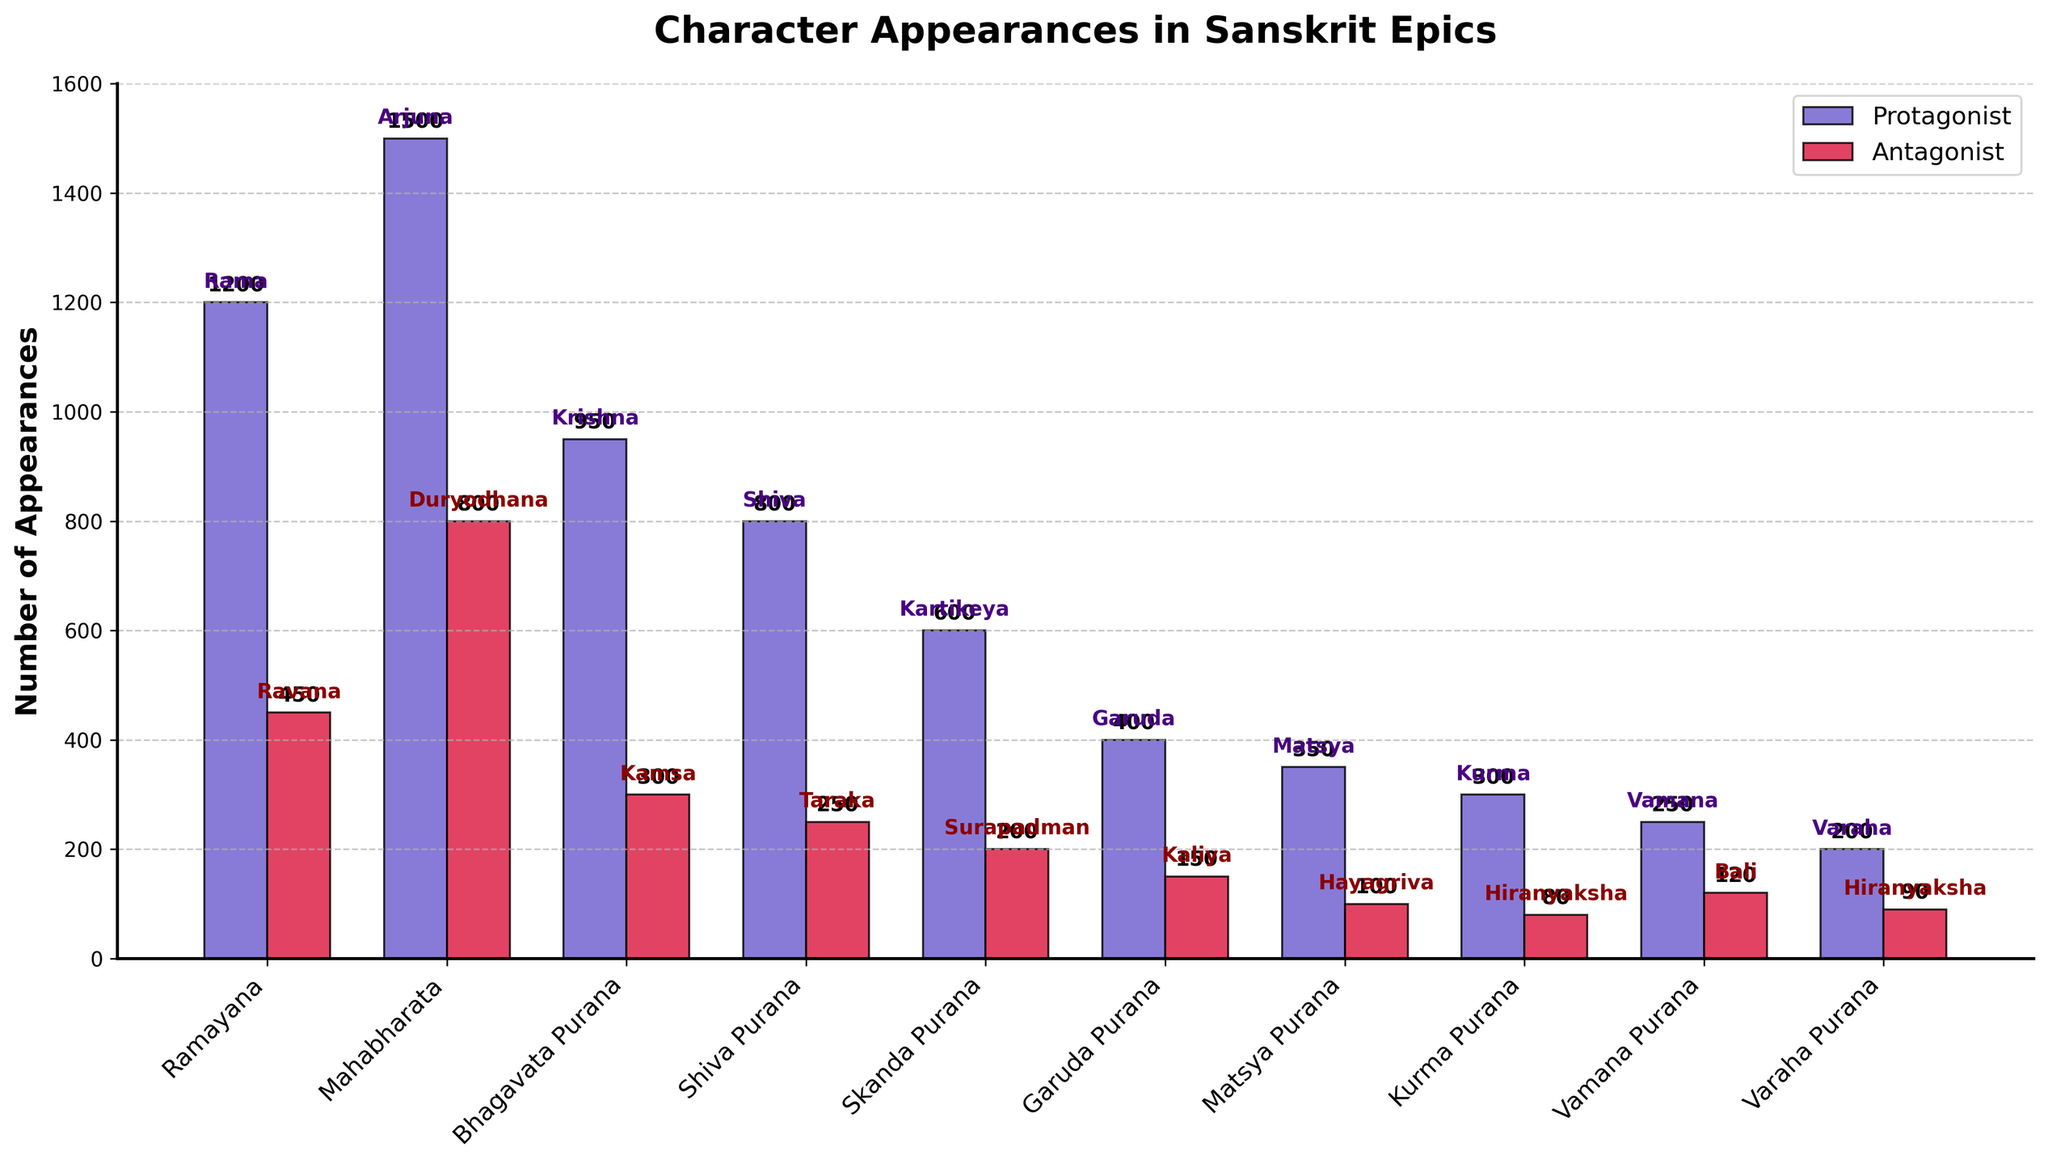Which epic has the highest number of protagonist appearances? Look at the bar chart to identify the bar with the greatest height in the 'Protagonist' category. The epic with the highest protagonist appearances is Mahabharata, with 1500 appearances by Arjuna.
Answer: Mahabharata How many more appearances does the protagonist in Ramayana have compared to the antagonist? Compare the heights of the protagonist and antagonist bars in the Ramayana section. Rama has 1200 appearances, and Ravana has 450. The difference is 1200 - 450.
Answer: 750 Which antagonist has the lowest number of appearances, and how many? Look at the lowest bar in the 'Antagonist' category. Hiranyaksha in Kurma Purana has the lowest appearances with a count of 80.
Answer: Hiranyaksha, 80 What is the average number of appearances of protagonists across all epics? Sum the appearances of all protagonists (1200 + 1500 + 950 + 800 + 600 + 400 + 350 + 300 + 250 + 200) and divide by the number of epics (10). The total is 6500 and the average is 6500/10.
Answer: 650 Which epic has a closer appearance count between protagonist and antagonist? Compare the difference between protagonist and antagonist appearances across each epic. The smallest difference is in Vamana Purana, where Vamana has 250 appearances and Bali has 120, with a difference of 130.
Answer: Vamana Purana How does the appearance count of Krishna in Bhagavata Purana compare to that of Arjuna in Mahabharata? Compare the heights of the protagonist bars for Bhagavata Purana and Mahabharata. Arjuna in Mahabharata has 1500 appearances, and Krishna in Bhagavata Purana has 950. Arjuna appears more frequently.
Answer: Arjuna appears more Which epic has the second highest number of antagonist appearances, and who is the antagonist? Identify the bars in the 'Antagonist' category and find the second tallest one. The epic is Mahabharata, with the antagonist Duryodhana having 800 appearances.
Answer: Mahabharata, Duryodhana What is the total number of appearances of antagonists in all the epics? Sum the appearances of all antagonists (450 + 800 + 300 + 250 + 200 + 150 + 100 + 80 + 120 + 90). The total is 2540.
Answer: 2540 